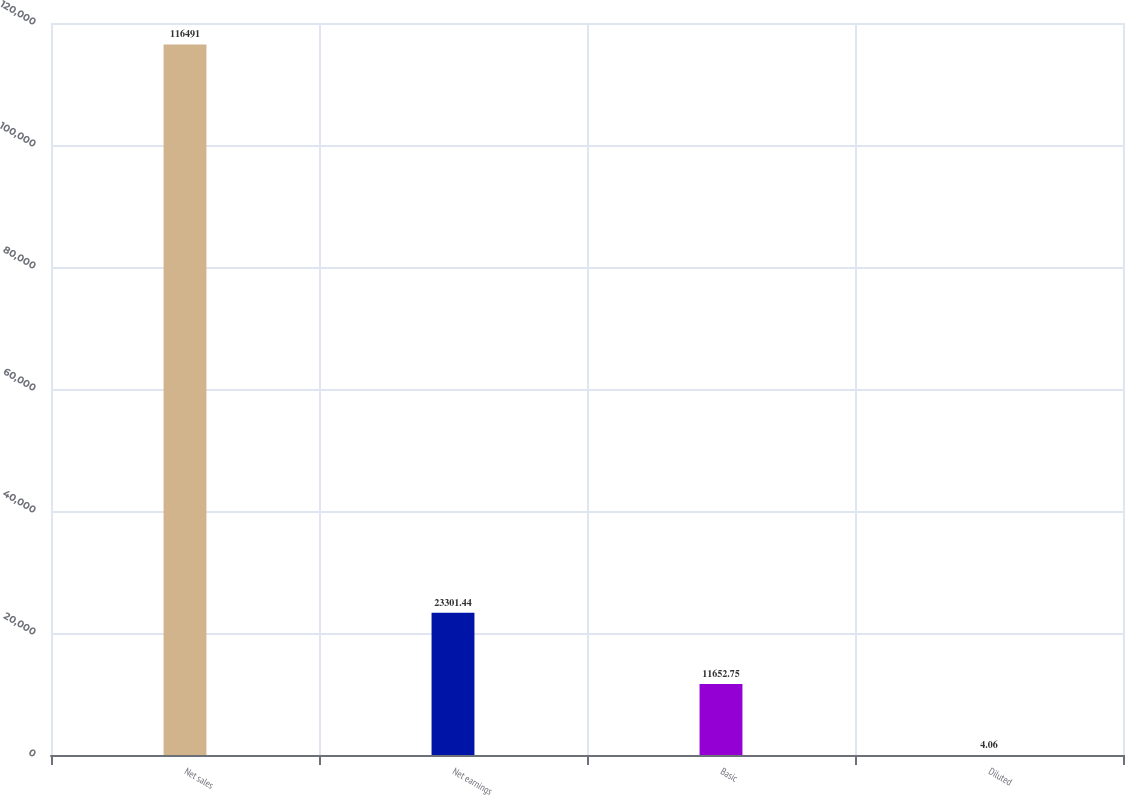Convert chart to OTSL. <chart><loc_0><loc_0><loc_500><loc_500><bar_chart><fcel>Net sales<fcel>Net earnings<fcel>Basic<fcel>Diluted<nl><fcel>116491<fcel>23301.4<fcel>11652.8<fcel>4.06<nl></chart> 